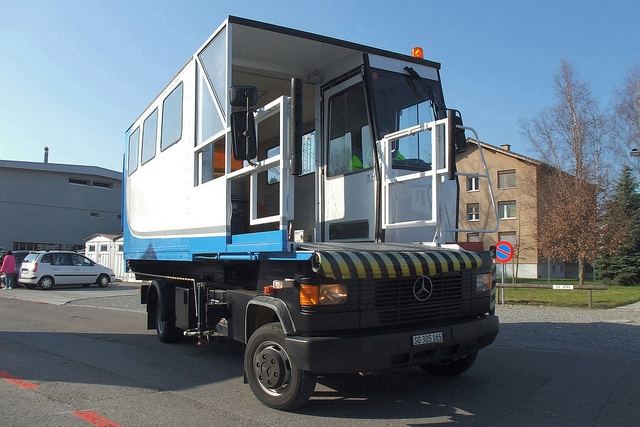Describe the objects in this image and their specific colors. I can see truck in lightblue, black, gray, white, and darkgray tones, car in lightblue, black, and gray tones, people in lightblue, purple, and black tones, stop sign in lightblue, red, gray, and salmon tones, and car in lightblue, black, gray, and blue tones in this image. 